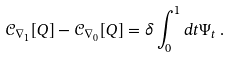Convert formula to latex. <formula><loc_0><loc_0><loc_500><loc_500>\mathcal { C } _ { \nabla _ { 1 } } [ Q ] - \mathcal { C } _ { \nabla _ { 0 } } [ Q ] = \delta \int _ { 0 } ^ { 1 } d t \Psi _ { t } \, .</formula> 